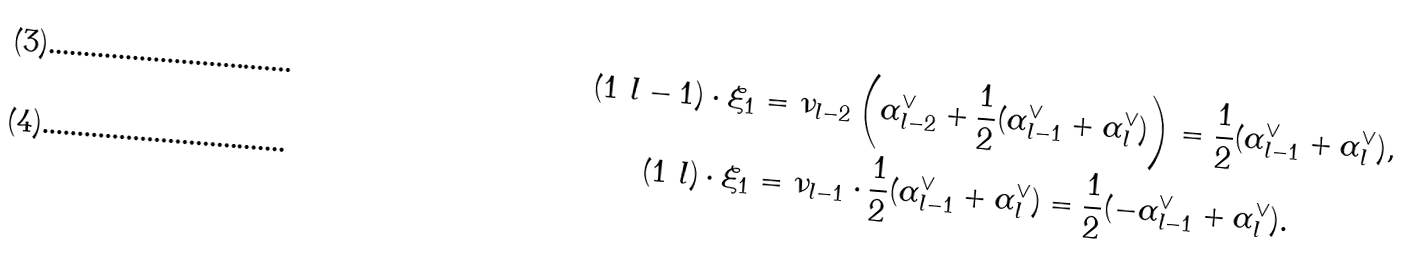<formula> <loc_0><loc_0><loc_500><loc_500>( 1 \ l - 1 ) \cdot \xi _ { 1 } & = \nu _ { l - 2 } \left ( \alpha ^ { \vee } _ { l - 2 } + \frac { 1 } { 2 } ( \alpha ^ { \vee } _ { l - 1 } + \alpha ^ { \vee } _ { l } ) \right ) = \frac { 1 } { 2 } ( \alpha ^ { \vee } _ { l - 1 } + \alpha ^ { \vee } _ { l } ) , \\ ( 1 \ l ) \cdot \xi _ { 1 } & = \nu _ { l - 1 } \cdot \frac { 1 } { 2 } ( \alpha ^ { \vee } _ { l - 1 } + \alpha ^ { \vee } _ { l } ) = \frac { 1 } { 2 } ( - \alpha ^ { \vee } _ { l - 1 } + \alpha ^ { \vee } _ { l } ) .</formula> 